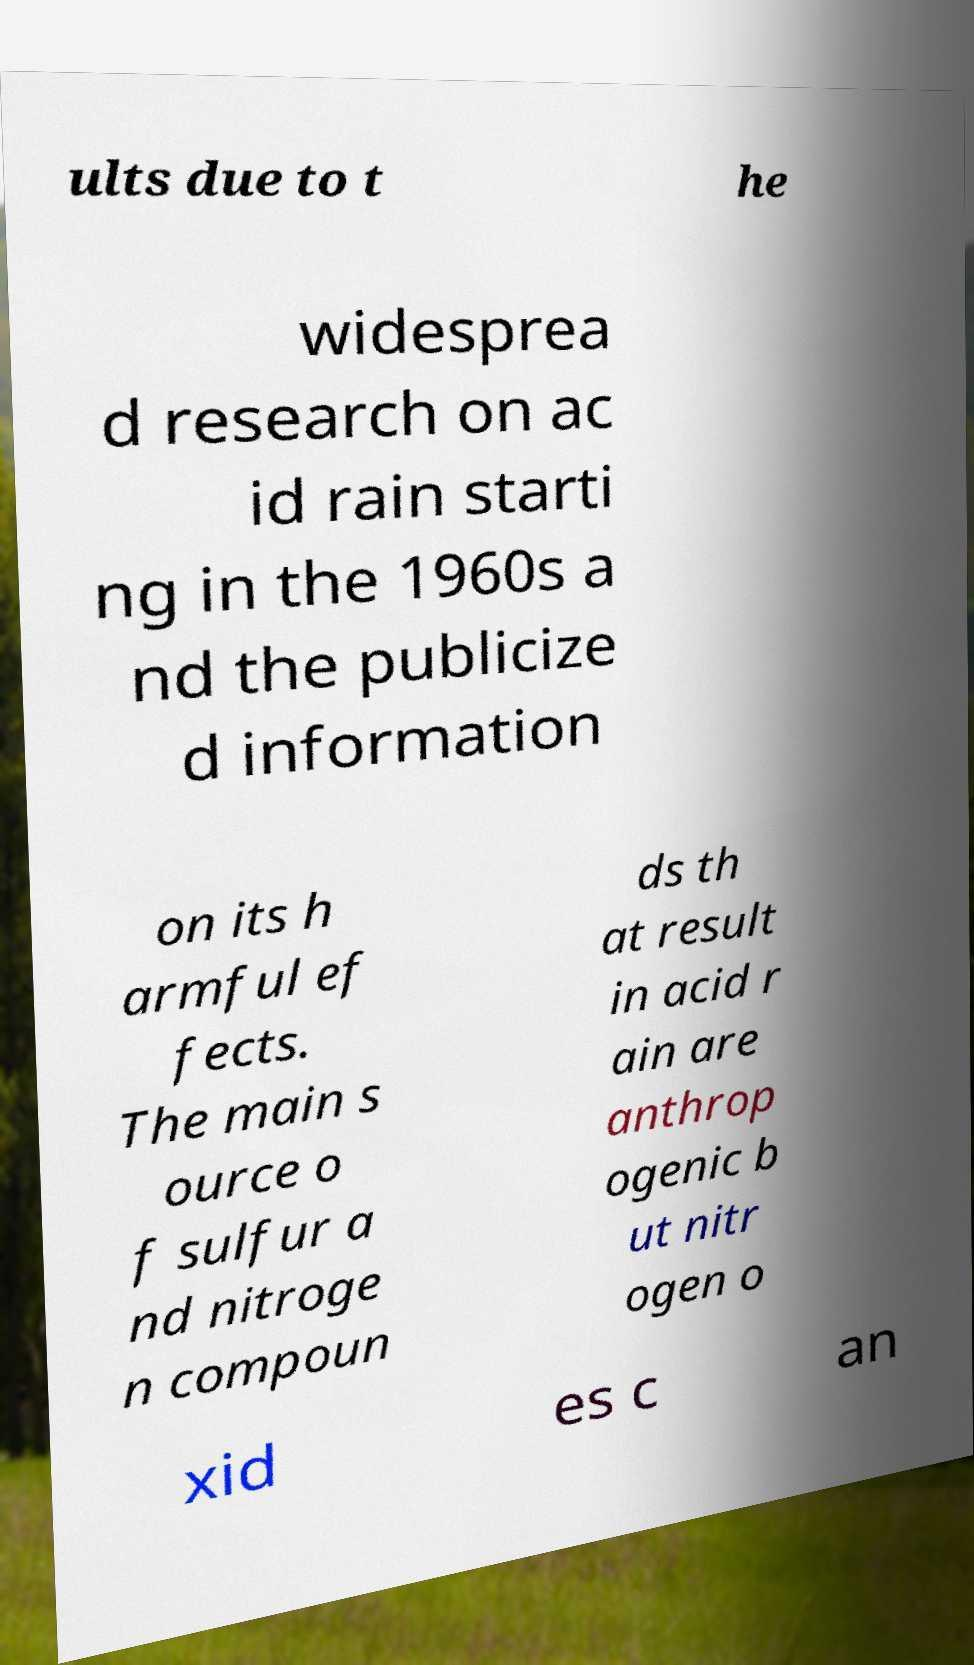There's text embedded in this image that I need extracted. Can you transcribe it verbatim? ults due to t he widesprea d research on ac id rain starti ng in the 1960s a nd the publicize d information on its h armful ef fects. The main s ource o f sulfur a nd nitroge n compoun ds th at result in acid r ain are anthrop ogenic b ut nitr ogen o xid es c an 